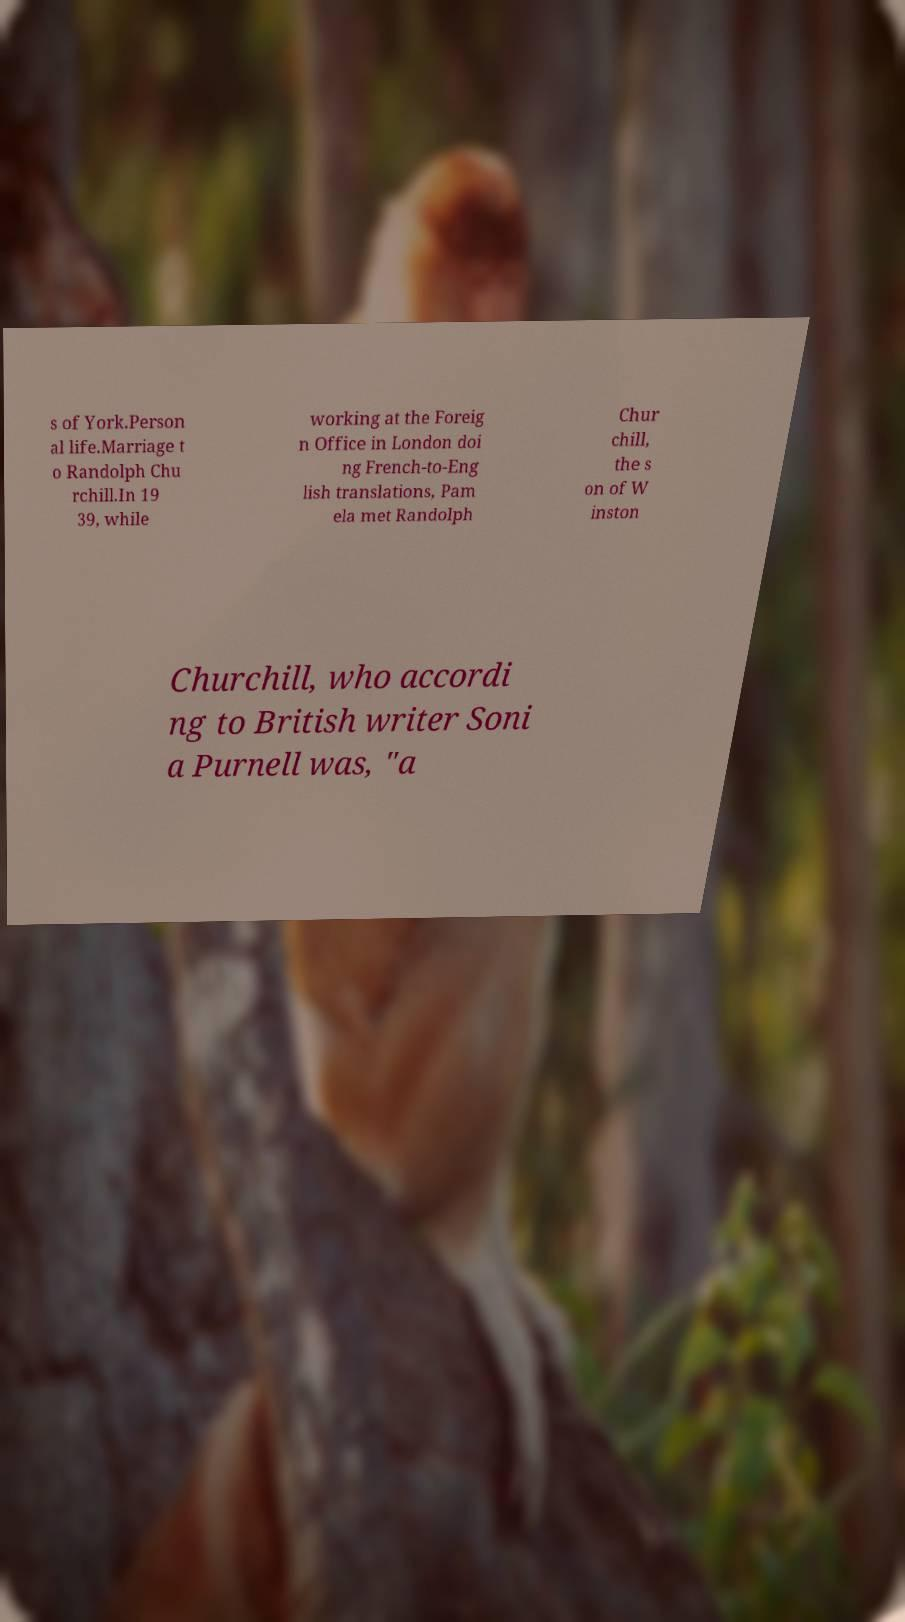Please read and relay the text visible in this image. What does it say? s of York.Person al life.Marriage t o Randolph Chu rchill.In 19 39, while working at the Foreig n Office in London doi ng French-to-Eng lish translations, Pam ela met Randolph Chur chill, the s on of W inston Churchill, who accordi ng to British writer Soni a Purnell was, "a 